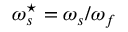<formula> <loc_0><loc_0><loc_500><loc_500>\omega _ { s } ^ { ^ { * } } = \omega _ { s } / \omega _ { f }</formula> 